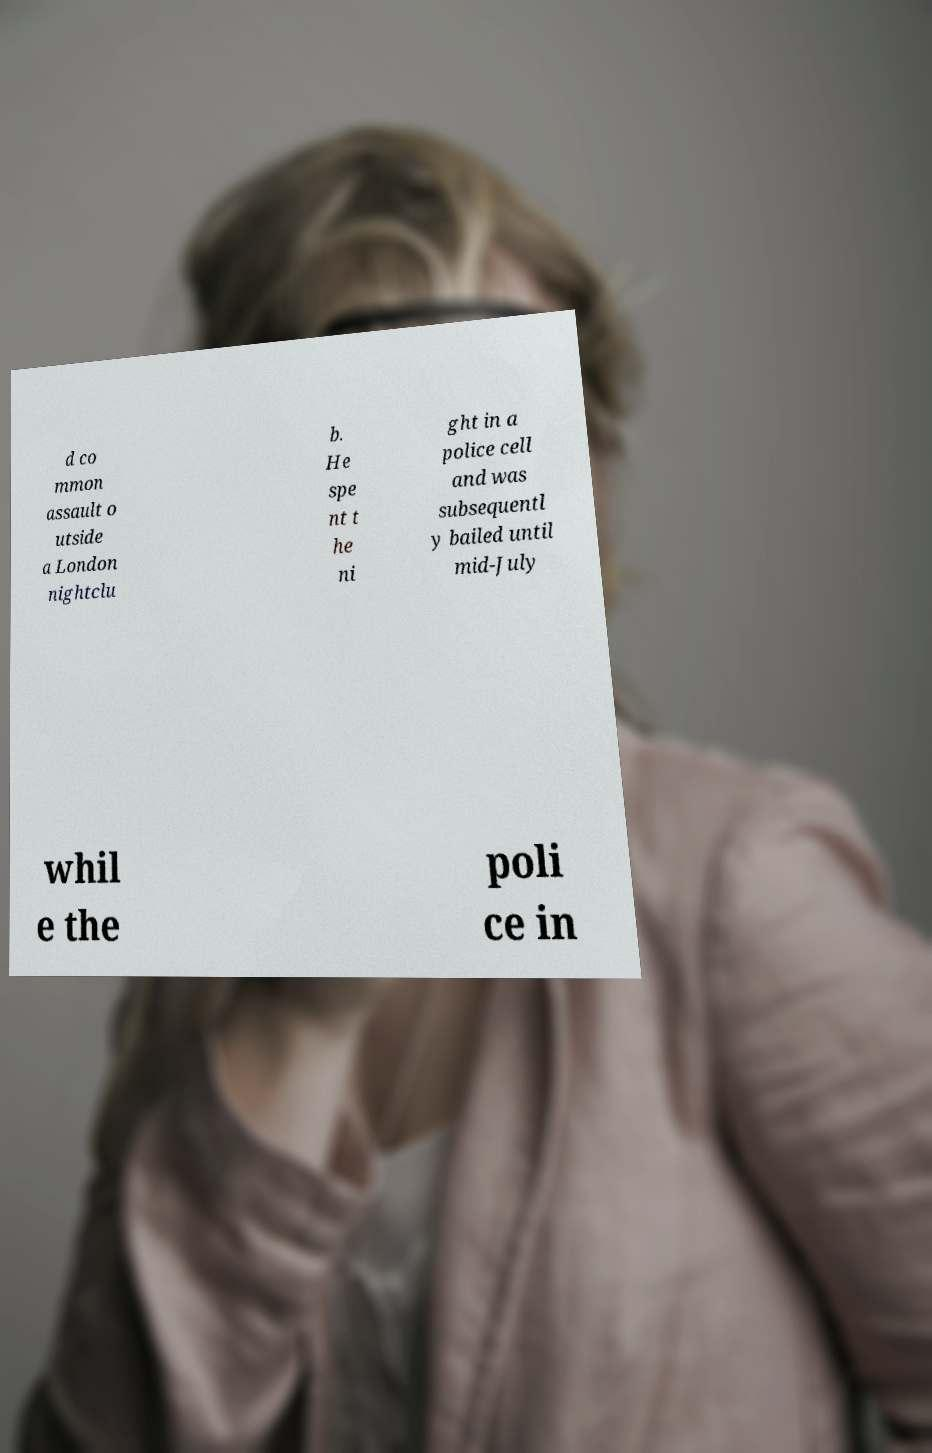For documentation purposes, I need the text within this image transcribed. Could you provide that? d co mmon assault o utside a London nightclu b. He spe nt t he ni ght in a police cell and was subsequentl y bailed until mid-July whil e the poli ce in 